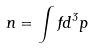<formula> <loc_0><loc_0><loc_500><loc_500>n = \int f d ^ { 3 } p</formula> 